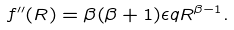<formula> <loc_0><loc_0><loc_500><loc_500>f ^ { \prime \prime } ( R ) = \beta ( \beta + 1 ) \epsilon q R ^ { \beta - 1 } .</formula> 